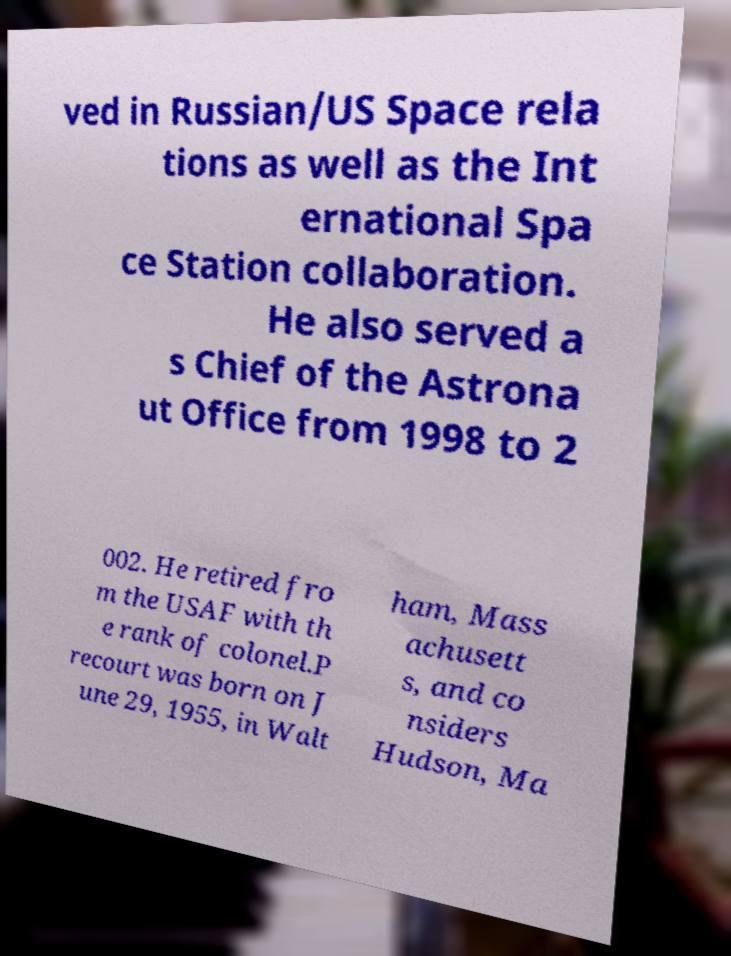What messages or text are displayed in this image? I need them in a readable, typed format. ved in Russian/US Space rela tions as well as the Int ernational Spa ce Station collaboration. He also served a s Chief of the Astrona ut Office from 1998 to 2 002. He retired fro m the USAF with th e rank of colonel.P recourt was born on J une 29, 1955, in Walt ham, Mass achusett s, and co nsiders Hudson, Ma 